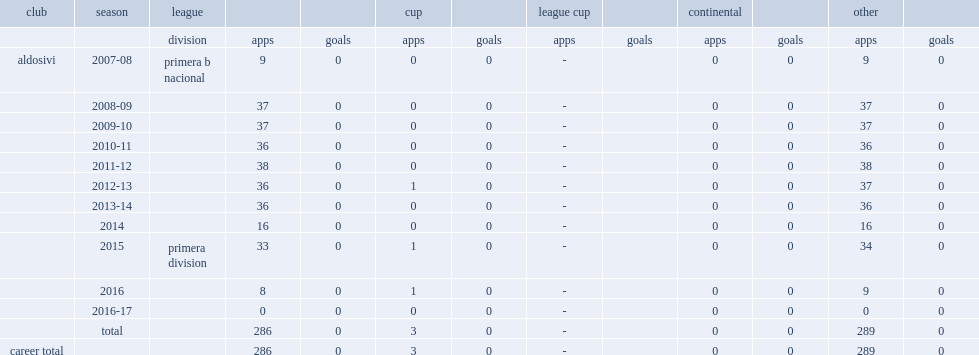What was the number of league appearances made by pablo campodonico for aldosivi totally? 286.0. 